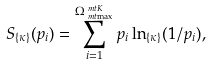Convert formula to latex. <formula><loc_0><loc_0><loc_500><loc_500>S _ { \{ \kappa \} } ( p _ { i } ) & = \sum _ { i = 1 } ^ { \Omega _ { \ m t { \max } } ^ { \ m t { K } } } p _ { i } \ln _ { \{ \kappa \} } ( 1 / p _ { i } ) ,</formula> 